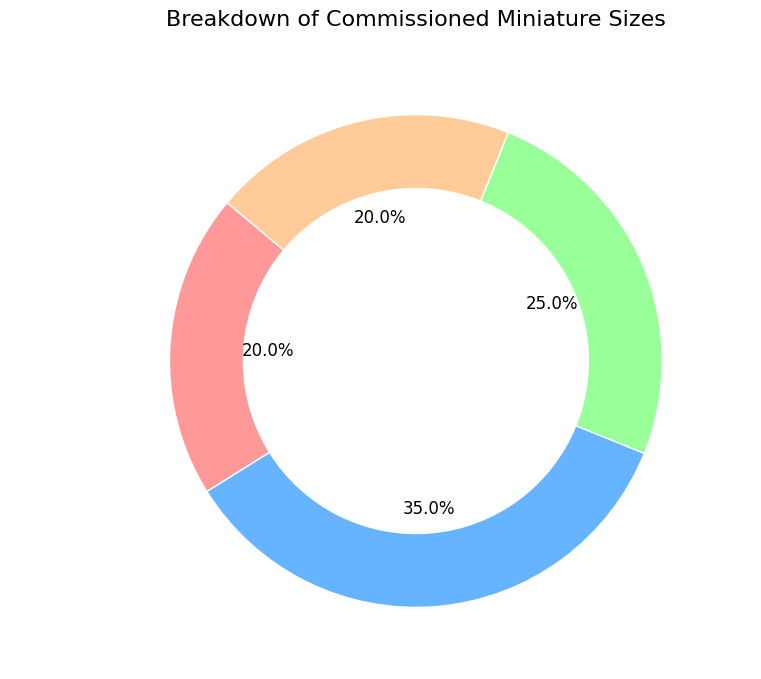What percentage of commissioned miniatures are between 1-2 inches? The pie chart shows each category and its corresponding percentage. The slice labeled "1-2 inches" shows 35%.
Answer: 35% What is the total percentage of miniatures that are either less than 1 inch or more than 3 inches? To find the total percentage, add the percentages for "Less than 1 inch" and "More than 3 inches." According to the chart, these are 20% and 20% respectively. Summing them gives 20% + 20% = 40%.
Answer: 40% Which size category makes up the largest proportion of commissioned miniatures? On the pie chart, the size category with the highest percentage indicates the largest proportion. The "1-2 inches" category has the largest slice at 35%.
Answer: 1-2 inches What is the difference in percentage between the largest and smallest categories? Identify the largest and smallest percentages. "1-2 inches" is the largest at 35%, and both "Less than 1 inch" and "More than 3 inches" are the smallest at 20%. The difference is 35% - 20% = 15%.
Answer: 15% Are there any categories that represent an equal percentage of the total miniature sizes? Look at the pie chart and compare the slices. Both "Less than 1 inch" and "More than 3 inches" each represent 20%.
Answer: Yes If you combine the percentages for miniatures ranging from 1 inch up to 3 inches, what percentage do they represent together? Sum the percentages of "1-2 inches" (35%) and "2-3 inches" (25%). Together, they represent 35% + 25% = 60%.
Answer: 60% What color is used to represent the "More than 3 inches" category, and what does this color imply in the context of the pie chart? Observe the segment of the pie chart labeled "More than 3 inches." It is colored in a light brown shade. This color visually distinguishes it from other categories.
Answer: Light brown If a collector wants to order miniatures likely to be either the smallest or the largest size, which two categories should they focus on based on the chart? The chart shows that the "Less than 1 inch" and "More than 3 inches" categories represent the smallest and largest sizes, respectively.
Answer: Less than 1 inch and More than 3 inches 